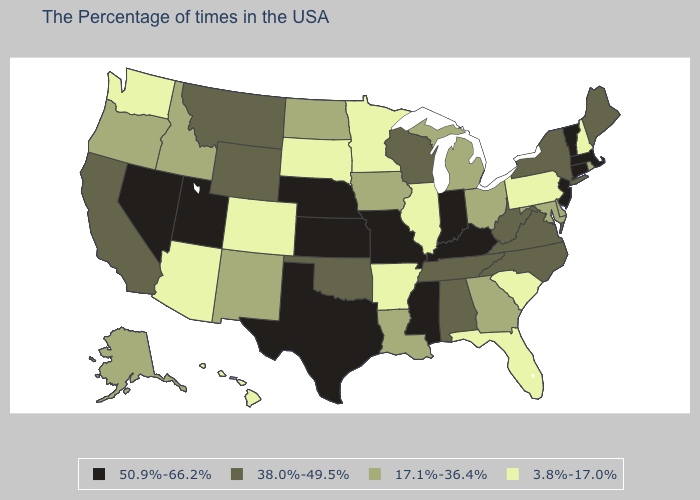Name the states that have a value in the range 38.0%-49.5%?
Be succinct. Maine, New York, Virginia, North Carolina, West Virginia, Alabama, Tennessee, Wisconsin, Oklahoma, Wyoming, Montana, California. Does New Hampshire have the lowest value in the USA?
Quick response, please. Yes. Among the states that border Montana , which have the lowest value?
Concise answer only. South Dakota. Name the states that have a value in the range 3.8%-17.0%?
Concise answer only. New Hampshire, Pennsylvania, South Carolina, Florida, Illinois, Arkansas, Minnesota, South Dakota, Colorado, Arizona, Washington, Hawaii. What is the highest value in the USA?
Be succinct. 50.9%-66.2%. Does the map have missing data?
Short answer required. No. What is the value of Utah?
Give a very brief answer. 50.9%-66.2%. Which states have the highest value in the USA?
Answer briefly. Massachusetts, Vermont, Connecticut, New Jersey, Kentucky, Indiana, Mississippi, Missouri, Kansas, Nebraska, Texas, Utah, Nevada. What is the lowest value in states that border Colorado?
Be succinct. 3.8%-17.0%. Does the map have missing data?
Concise answer only. No. Does the first symbol in the legend represent the smallest category?
Give a very brief answer. No. What is the highest value in the USA?
Be succinct. 50.9%-66.2%. Name the states that have a value in the range 50.9%-66.2%?
Answer briefly. Massachusetts, Vermont, Connecticut, New Jersey, Kentucky, Indiana, Mississippi, Missouri, Kansas, Nebraska, Texas, Utah, Nevada. Among the states that border Connecticut , which have the highest value?
Be succinct. Massachusetts. Which states have the lowest value in the South?
Short answer required. South Carolina, Florida, Arkansas. 